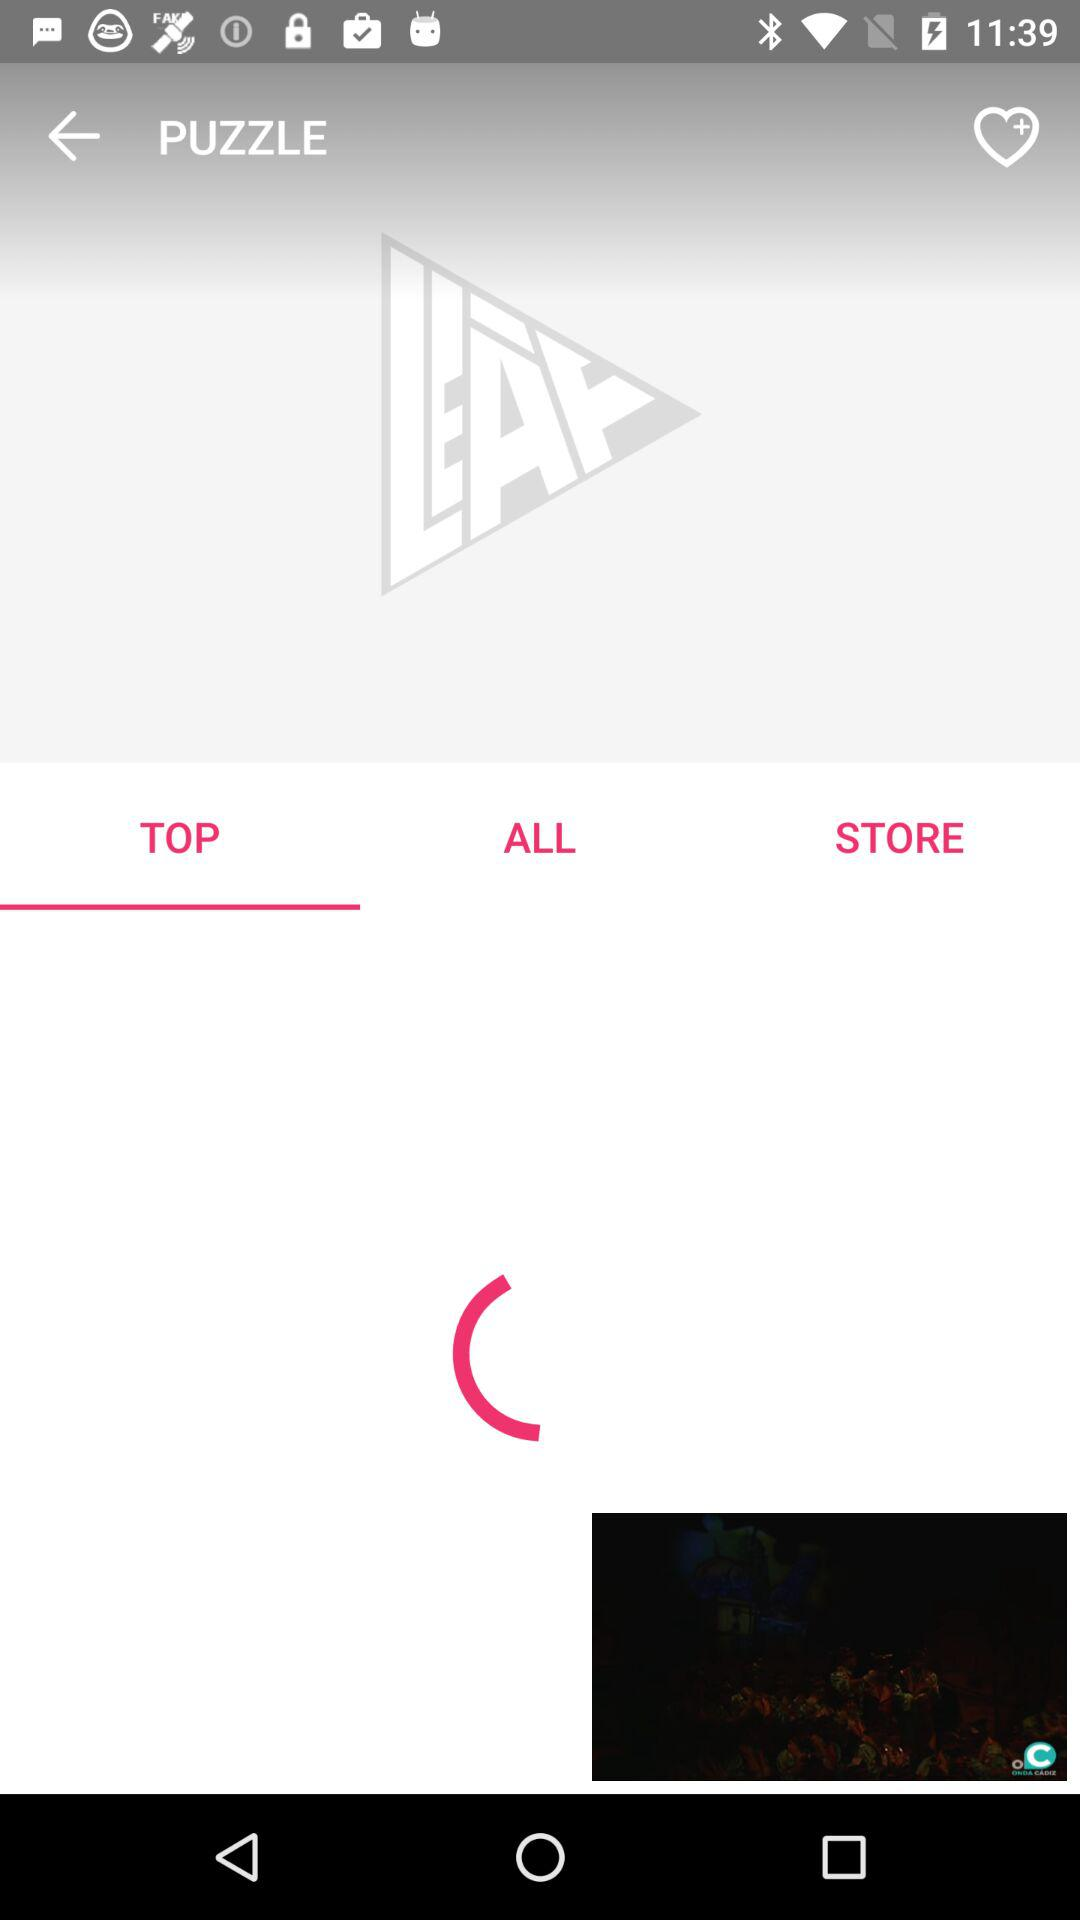Which tab is selected? The selected tab is "TOP". 